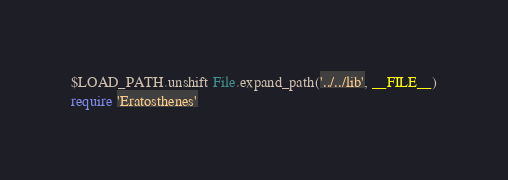Convert code to text. <code><loc_0><loc_0><loc_500><loc_500><_Ruby_>$LOAD_PATH.unshift File.expand_path('../../lib', __FILE__)
require 'Eratosthenes'
</code> 